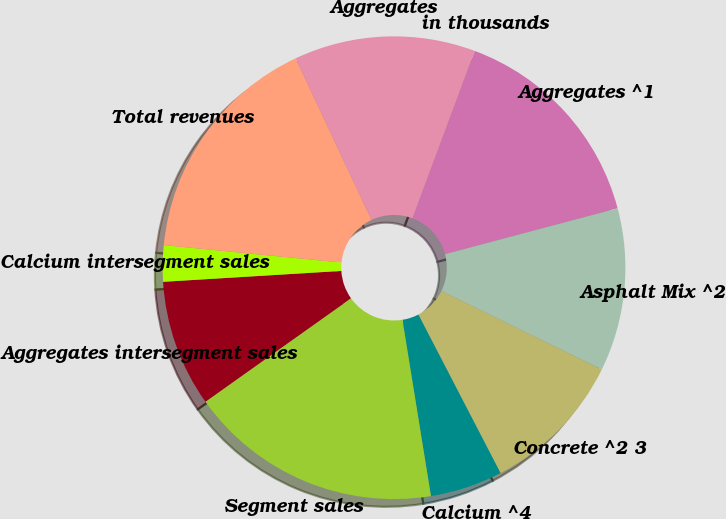<chart> <loc_0><loc_0><loc_500><loc_500><pie_chart><fcel>in thousands<fcel>Aggregates ^1<fcel>Asphalt Mix ^2<fcel>Concrete ^2 3<fcel>Calcium ^4<fcel>Segment sales<fcel>Aggregates intersegment sales<fcel>Calcium intersegment sales<fcel>Total revenues<fcel>Aggregates<nl><fcel>0.0%<fcel>15.19%<fcel>11.39%<fcel>10.13%<fcel>5.06%<fcel>17.72%<fcel>8.86%<fcel>2.53%<fcel>16.45%<fcel>12.66%<nl></chart> 